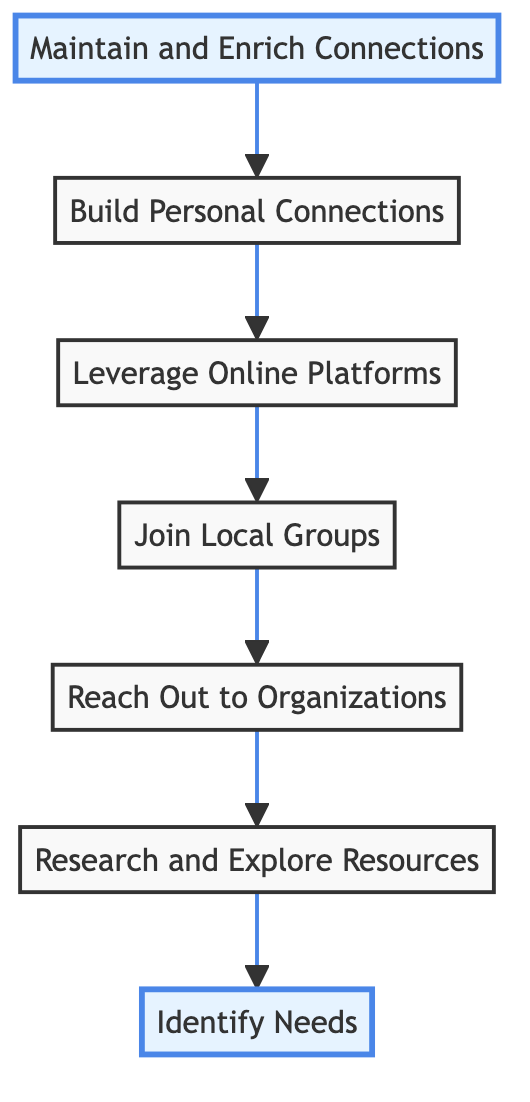What is the first stage of building a support network after service? The diagram starts with the node at the bottom, labeled "Identify Needs," which is the initial stage in the process of building a support network.
Answer: Identify Needs What is the last stage in the process? The uppermost node in the diagram shows "Maintain and Enrich Connections," indicating it is the final stage of building a support network after service.
Answer: Maintain and Enrich Connections How many total stages are there in the diagram? By counting the nodes in the diagram, there are seven distinct stages, represented by seven different nodes.
Answer: 7 What follows "Join Local Groups" in the flow? The flow proceeds from "Join Local Groups" to "Leverage Online Platforms," indicating that online platform engagement comes next.
Answer: Leverage Online Platforms Which stage directly leads to "Research and Explore Resources"? The flow shows that "Reach Out to Organizations" directly leads to "Research and Explore Resources," meaning the organization outreach comes before researching resources.
Answer: Reach Out to Organizations What is the relationship between "Build Personal Connections" and "Maintain and Enrich Connections"? The diagram indicates that "Build Personal Connections" is a prerequisite to "Maintain and Enrich Connections," as indicated by the directional arrow connecting the two stages.
Answer: Prerequisite If someone starts at "Identify Needs," how many steps are there to "Maintain and Enrich Connections"? Starting from "Identify Needs," the flow moves up through six stages to arrive at "Maintain and Enrich Connections," counting all stages traversed.
Answer: 6 Which two stages form the central part of the network process? The central stages are "Reach Out to Organizations" and "Join Local Groups," as they are positioned in the middle of the flowchart and represent important interactions.
Answer: Reach Out to Organizations and Join Local Groups What is the purpose of "Leverage Online Platforms"? "Leverage Online Platforms" aims to extend one's network by utilizing various online channels, which is crucial for building connections in the digital age.
Answer: Extend network 